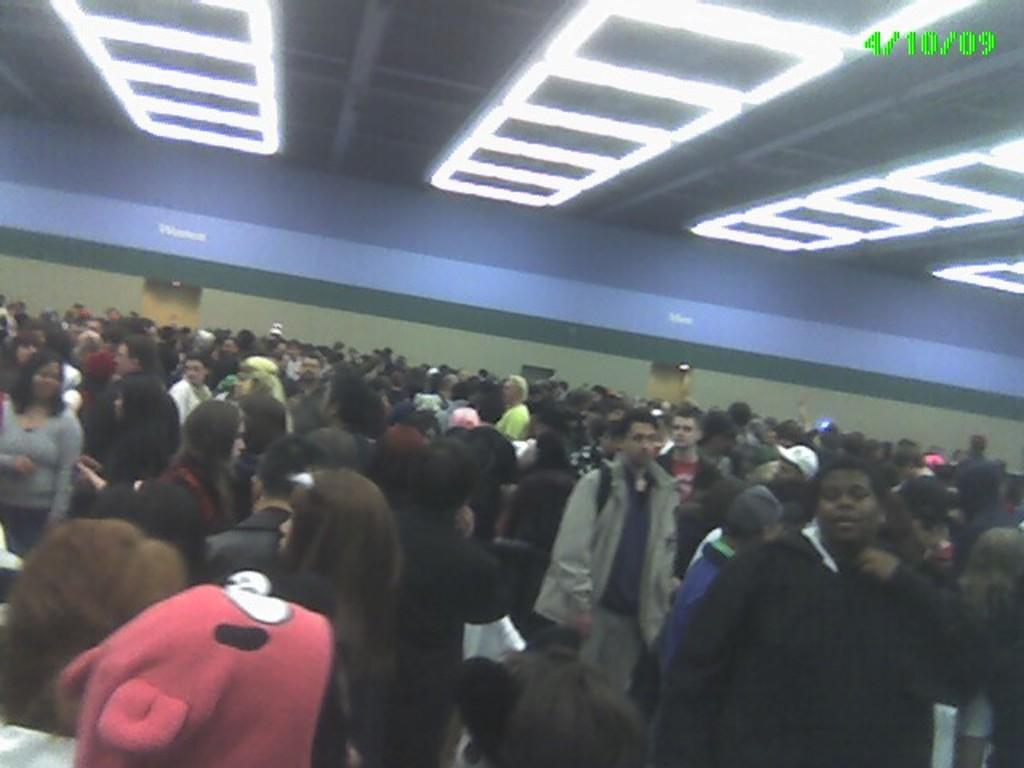What is the main subject of the image? The main subject of the image is a crowd. Can you describe the lighting in the image? There are lights on the ceiling in the image. Is there any additional information or branding in the image? Yes, there is a watermark in the top left corner of the image. How many kittens can be seen playing with a tank in the image? There are no kittens or tanks present in the image; it features a crowd and lights on the ceiling. 